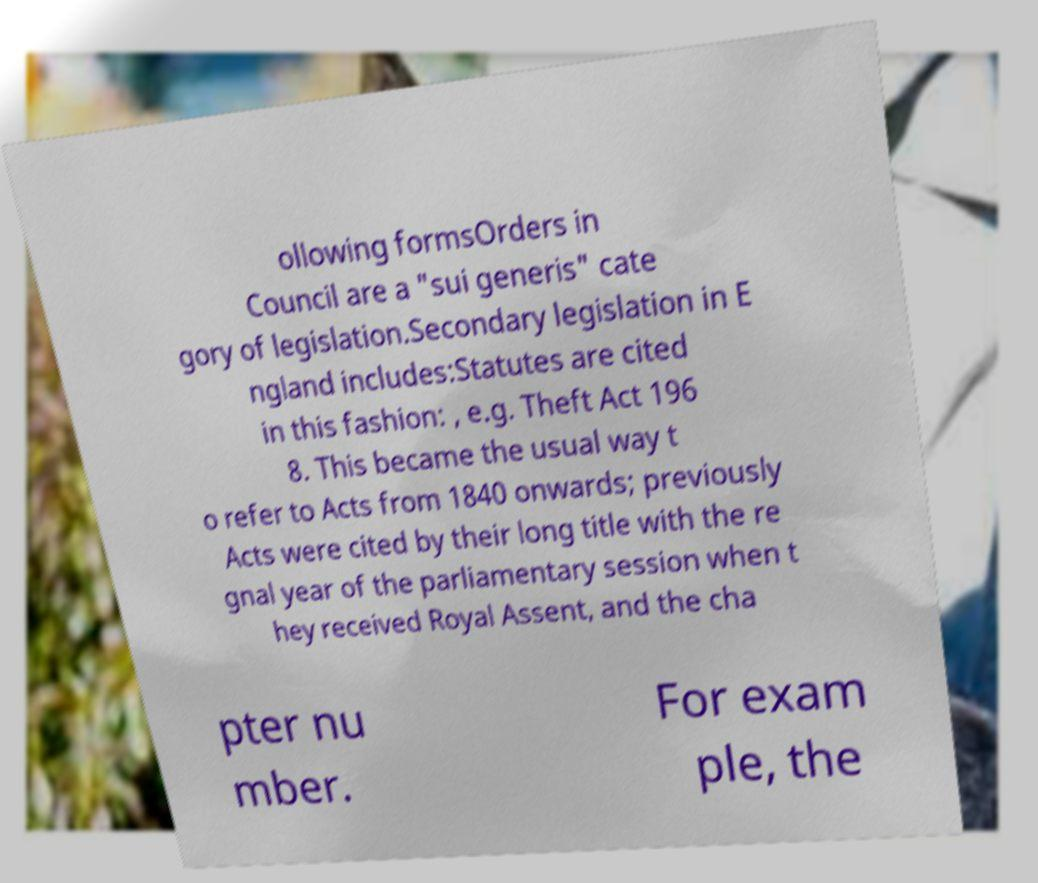Please read and relay the text visible in this image. What does it say? ollowing formsOrders in Council are a "sui generis" cate gory of legislation.Secondary legislation in E ngland includes:Statutes are cited in this fashion: , e.g. Theft Act 196 8. This became the usual way t o refer to Acts from 1840 onwards; previously Acts were cited by their long title with the re gnal year of the parliamentary session when t hey received Royal Assent, and the cha pter nu mber. For exam ple, the 